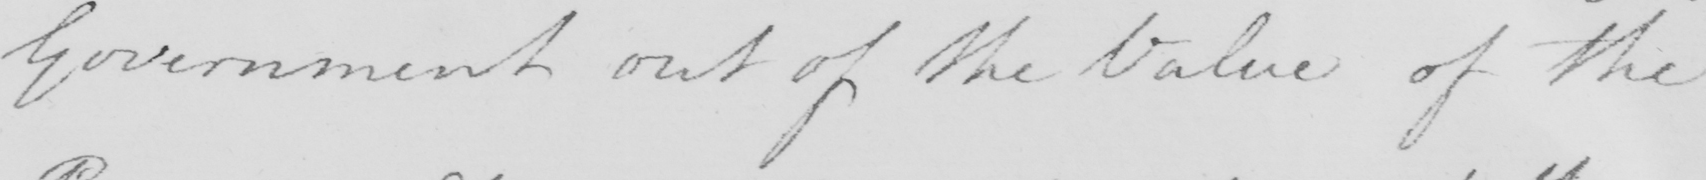Please transcribe the handwritten text in this image. Government out of the Value of the 